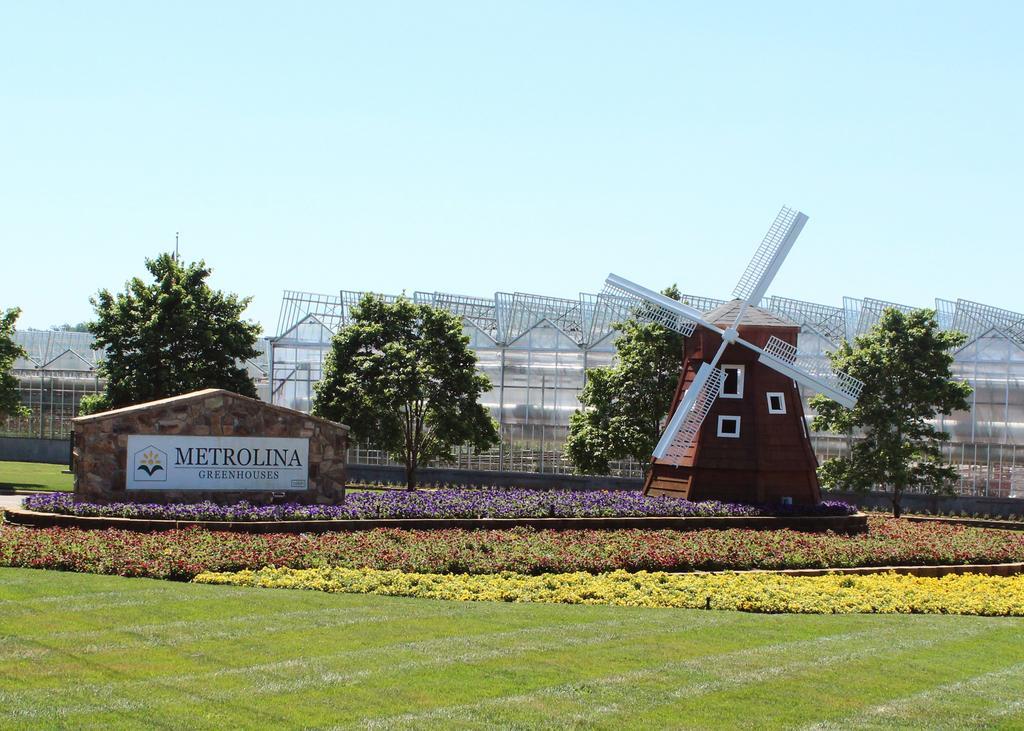Please provide a concise description of this image. In this image there are like a few shades, which are transparent, in front of them there are trees, wind mill and there is a wall with board. On the board there is some text, around the wall there are flowers, plants and grass. In the background there is this sky. 